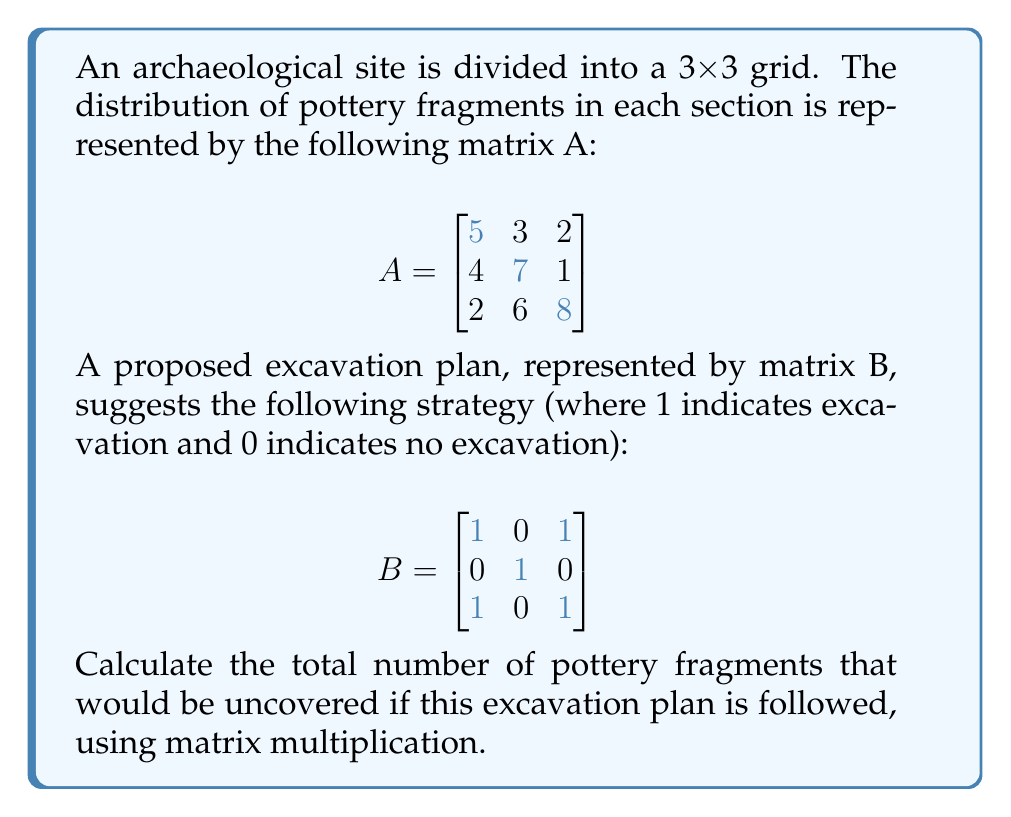Provide a solution to this math problem. To solve this problem, we need to perform matrix multiplication between matrices A and B. The resulting matrix will represent the number of pottery fragments uncovered in each excavated section.

Step 1: Multiply matrices A and B
$$AB = \begin{bmatrix}
5 & 3 & 2 \\
4 & 7 & 1 \\
2 & 6 & 8
\end{bmatrix} \times
\begin{bmatrix}
1 & 0 & 1 \\
0 & 1 & 0 \\
1 & 0 & 1
\end{bmatrix}$$

Step 2: Perform the multiplication
$$(AB)_{11} = 5(1) + 3(0) + 2(1) = 7$$
$$(AB)_{12} = 5(0) + 3(1) + 2(0) = 3$$
$$(AB)_{13} = 5(1) + 3(0) + 2(1) = 7$$
$$(AB)_{21} = 4(1) + 7(0) + 1(1) = 5$$
$$(AB)_{22} = 4(0) + 7(1) + 1(0) = 7$$
$$(AB)_{23} = 4(1) + 7(0) + 1(1) = 5$$
$$(AB)_{31} = 2(1) + 6(0) + 8(1) = 10$$
$$(AB)_{32} = 2(0) + 6(1) + 8(0) = 6$$
$$(AB)_{33} = 2(1) + 6(0) + 8(1) = 10$$

The resulting matrix is:
$$AB = \begin{bmatrix}
7 & 3 & 7 \\
5 & 7 & 5 \\
10 & 6 & 10
\end{bmatrix}$$

Step 3: Sum all elements in the resulting matrix
Total fragments = 7 + 3 + 7 + 5 + 7 + 5 + 10 + 6 + 10 = 60

Therefore, the total number of pottery fragments that would be uncovered following this excavation plan is 60.
Answer: 60 pottery fragments 